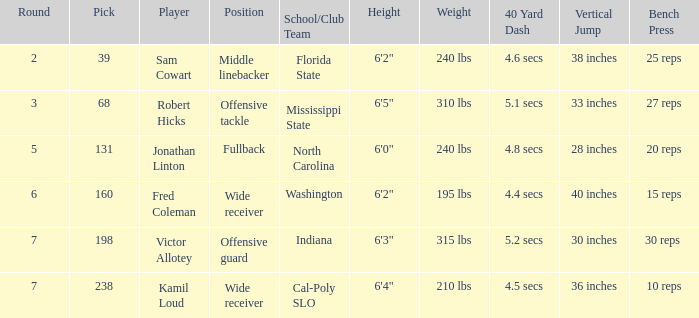Which School/Club Team has a Pick of 198? Indiana. 